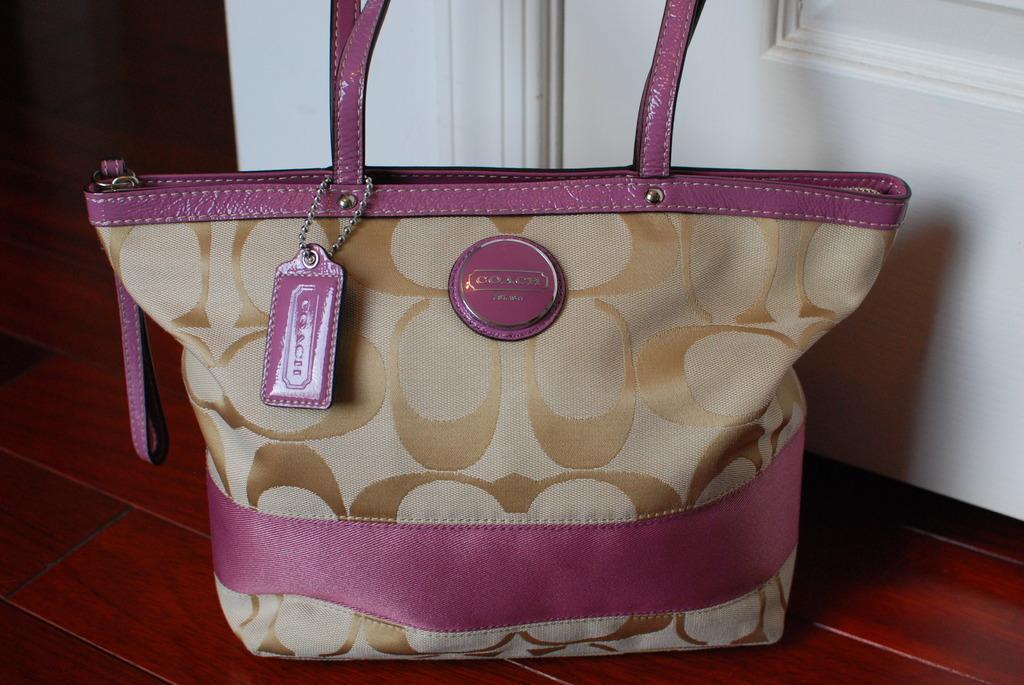How would you summarize this image in a sentence or two? This picture shows a bag which is in pink and biscuit color, placed on the floor. In the background there is a door. 